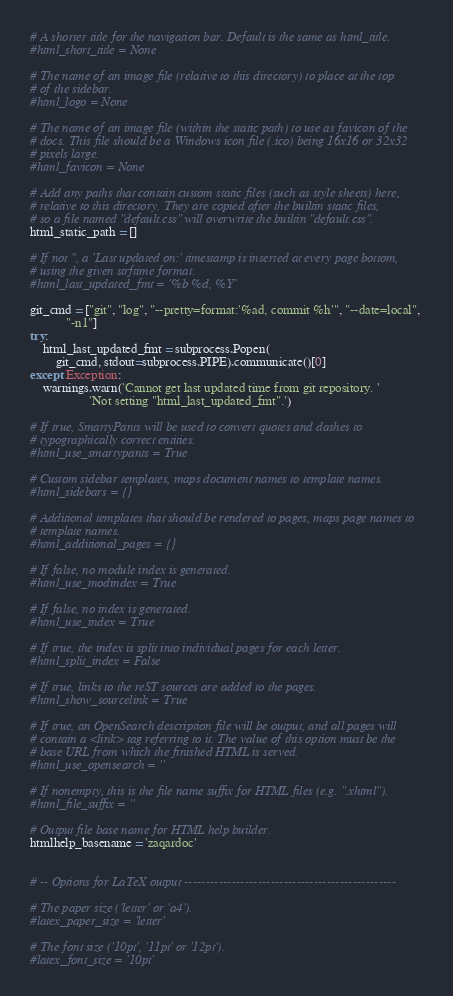Convert code to text. <code><loc_0><loc_0><loc_500><loc_500><_Python_># A shorter title for the navigation bar. Default is the same as html_title.
#html_short_title = None

# The name of an image file (relative to this directory) to place at the top
# of the sidebar.
#html_logo = None

# The name of an image file (within the static path) to use as favicon of the
# docs. This file should be a Windows icon file (.ico) being 16x16 or 32x32
# pixels large.
#html_favicon = None

# Add any paths that contain custom static files (such as style sheets) here,
# relative to this directory. They are copied after the builtin static files,
# so a file named "default.css" will overwrite the builtin "default.css".
html_static_path = []

# If not '', a 'Last updated on:' timestamp is inserted at every page bottom,
# using the given strftime format.
#html_last_updated_fmt = '%b %d, %Y'

git_cmd = ["git", "log", "--pretty=format:'%ad, commit %h'", "--date=local",
           "-n1"]
try:
    html_last_updated_fmt = subprocess.Popen(
        git_cmd, stdout=subprocess.PIPE).communicate()[0]
except Exception:
    warnings.warn('Cannot get last updated time from git repository. '
                  'Not setting "html_last_updated_fmt".')

# If true, SmartyPants will be used to convert quotes and dashes to
# typographically correct entities.
#html_use_smartypants = True

# Custom sidebar templates, maps document names to template names.
#html_sidebars = {}

# Additional templates that should be rendered to pages, maps page names to
# template names.
#html_additional_pages = {}

# If false, no module index is generated.
#html_use_modindex = True

# If false, no index is generated.
#html_use_index = True

# If true, the index is split into individual pages for each letter.
#html_split_index = False

# If true, links to the reST sources are added to the pages.
#html_show_sourcelink = True

# If true, an OpenSearch description file will be output, and all pages will
# contain a <link> tag referring to it. The value of this option must be the
# base URL from which the finished HTML is served.
#html_use_opensearch = ''

# If nonempty, this is the file name suffix for HTML files (e.g. ".xhtml").
#html_file_suffix = ''

# Output file base name for HTML help builder.
htmlhelp_basename = 'zaqardoc'


# -- Options for LaTeX output -------------------------------------------------

# The paper size ('letter' or 'a4').
#latex_paper_size = 'letter'

# The font size ('10pt', '11pt' or '12pt').
#latex_font_size = '10pt'
</code> 